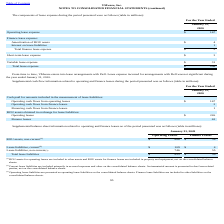According to Vmware's financial document, What were the current lease liabilities for operating leases? According to the financial document, 109 (in millions). The relevant text states: "Lease liabilities, current (2) $ 109 $ 4..." Also, What were the total lease liabilities for finance leases? According to the financial document, 59 (in millions). The relevant text states: "Total lease liabilities $ 855 $ 59..." Also, Where are ROU assets for operating leases included in the consolidated balance sheets? ROU assets for operating leases are included in other assets and ROU assets for finance leases are included in property and equipment, net. The document states: "(1) ROU assets for operating leases are included in other assets and ROU assets for finance leases are included in property and equipment, net on the ..." Also, How many lease liabilities for operating leases exceeded $500 million? Based on the analysis, there are 1 instances. The counting process: Lease liabilities, non-current. Also, can you calculate: What was the difference between current and non-current lease liabilities for operating leases? Based on the calculation: 746-109, the result is 637 (in millions). This is based on the information: "Lease liabilities, current (2) $ 109 $ 4 Lease liabilities, non-current (3) 746 55..." The key data points involved are: 109, 746. Also, can you calculate: What was the difference in total lease liabilities between operating leases and finance leases? Based on the calculation: 855-59, the result is 796 (in millions). This is based on the information: "Total lease liabilities $ 855 $ 59 Total lease liabilities $ 855 $ 59..." The key data points involved are: 59, 855. 